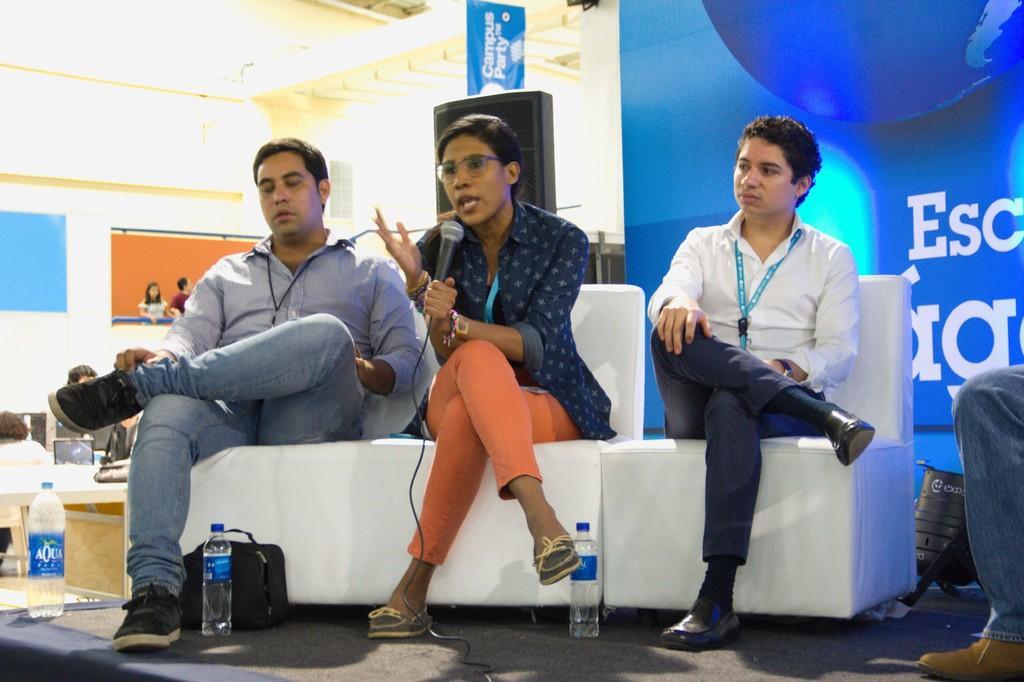Describe this image in one or two sentences. In this image there are three persons sitting on chairs, one person is holding a mic in her hand at the bottom there are bottles and box, on the right side there is a leg, in the background there is a poster on that poster there is some text. 